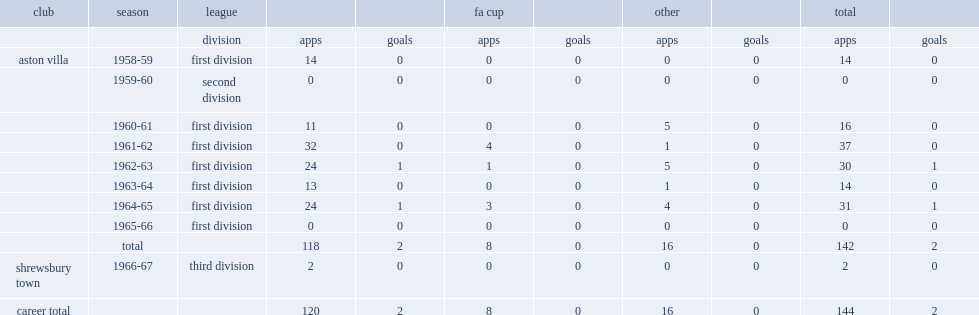Parse the full table. {'header': ['club', 'season', 'league', '', '', 'fa cup', '', 'other', '', 'total', ''], 'rows': [['', '', 'division', 'apps', 'goals', 'apps', 'goals', 'apps', 'goals', 'apps', 'goals'], ['aston villa', '1958-59', 'first division', '14', '0', '0', '0', '0', '0', '14', '0'], ['', '1959-60', 'second division', '0', '0', '0', '0', '0', '0', '0', '0'], ['', '1960-61', 'first division', '11', '0', '0', '0', '5', '0', '16', '0'], ['', '1961-62', 'first division', '32', '0', '4', '0', '1', '0', '37', '0'], ['', '1962-63', 'first division', '24', '1', '1', '0', '5', '0', '30', '1'], ['', '1963-64', 'first division', '13', '0', '0', '0', '1', '0', '14', '0'], ['', '1964-65', 'first division', '24', '1', '3', '0', '4', '0', '31', '1'], ['', '1965-66', 'first division', '0', '0', '0', '0', '0', '0', '0', '0'], ['', 'total', '', '118', '2', '8', '0', '16', '0', '142', '2'], ['shrewsbury town', '1966-67', 'third division', '2', '0', '0', '0', '0', '0', '2', '0'], ['career total', '', '', '120', '2', '8', '0', '16', '0', '144', '2']]} What was the total number of appearances made by lee for villa? 142.0. 